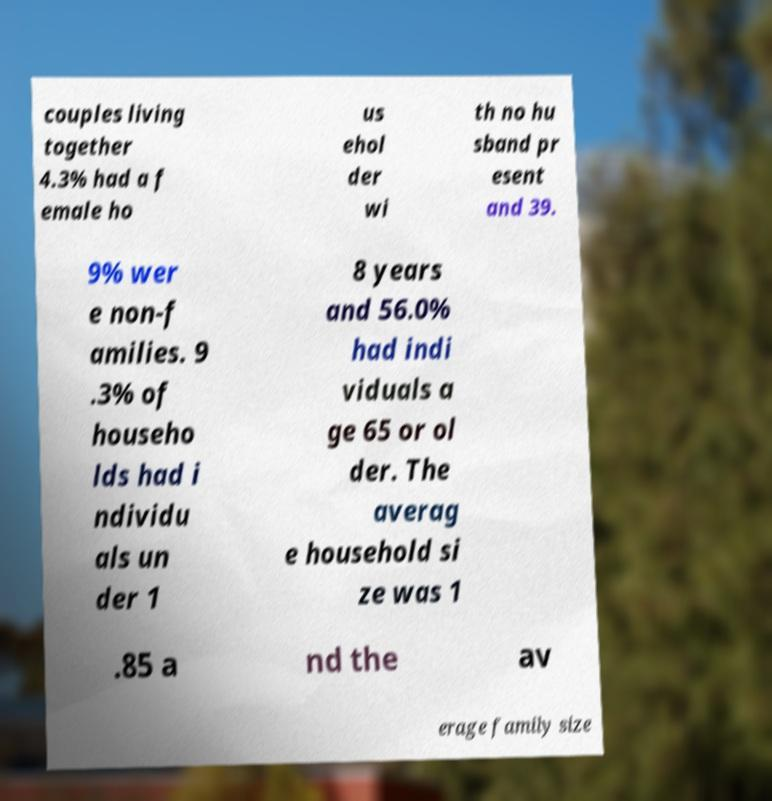Could you extract and type out the text from this image? couples living together 4.3% had a f emale ho us ehol der wi th no hu sband pr esent and 39. 9% wer e non-f amilies. 9 .3% of househo lds had i ndividu als un der 1 8 years and 56.0% had indi viduals a ge 65 or ol der. The averag e household si ze was 1 .85 a nd the av erage family size 